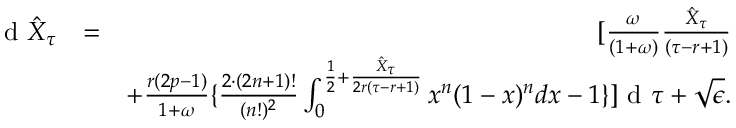<formula> <loc_0><loc_0><loc_500><loc_500>\begin{array} { r l r } { d \hat { X } _ { \tau } } & { = } & { [ \frac { \omega } { ( 1 + \omega ) } \frac { \hat { X } _ { \tau } } { ( \tau - r + 1 ) } } \\ & { + \frac { r ( 2 p - 1 ) } { 1 + \omega } \{ \frac { 2 \cdot ( 2 n + 1 ) ! } { ( n ! ) ^ { 2 } } \int _ { 0 } ^ { \frac { 1 } { 2 } + \frac { \hat { X } _ { \tau } } { 2 r ( \tau - r + 1 ) } } x ^ { n } ( 1 - x ) ^ { n } d x - 1 \} ] d \tau + \sqrt { \epsilon } . } \end{array}</formula> 